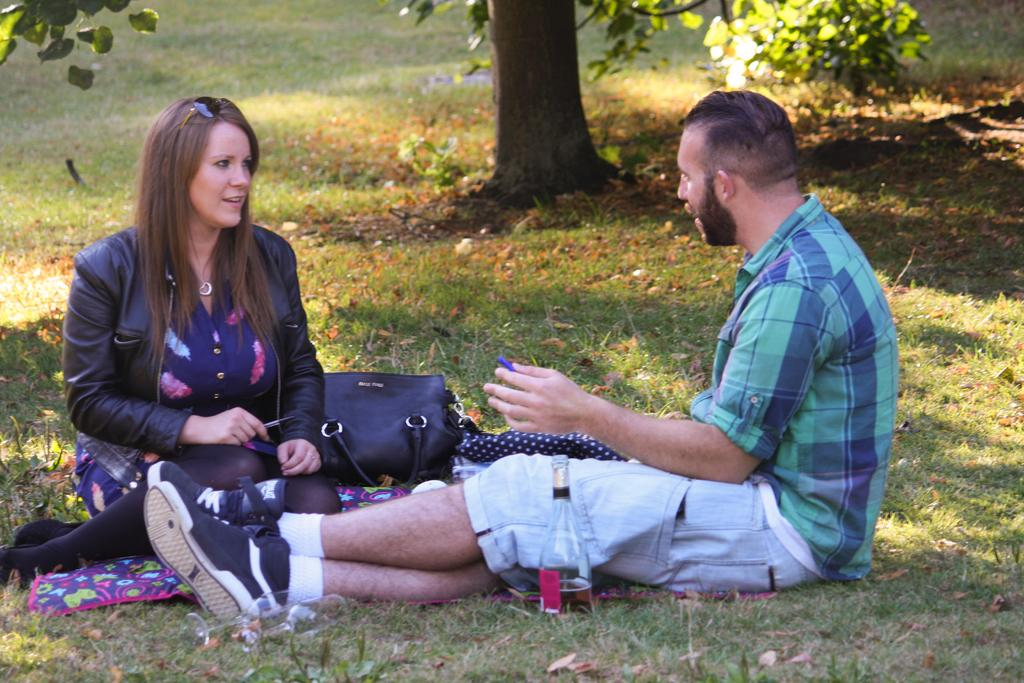What is the main setting of the image? There is a garden in the image. Are there any people present in the garden? Yes, there are two persons sitting in the garden. What can be seen in the background of the image? There is a tree in the background of the image. What type of letters are being exchanged between the two persons in the image? There is no indication in the image that the two persons are exchanging letters. Can you see a lamp in the image? There is no lamp present in the image. 